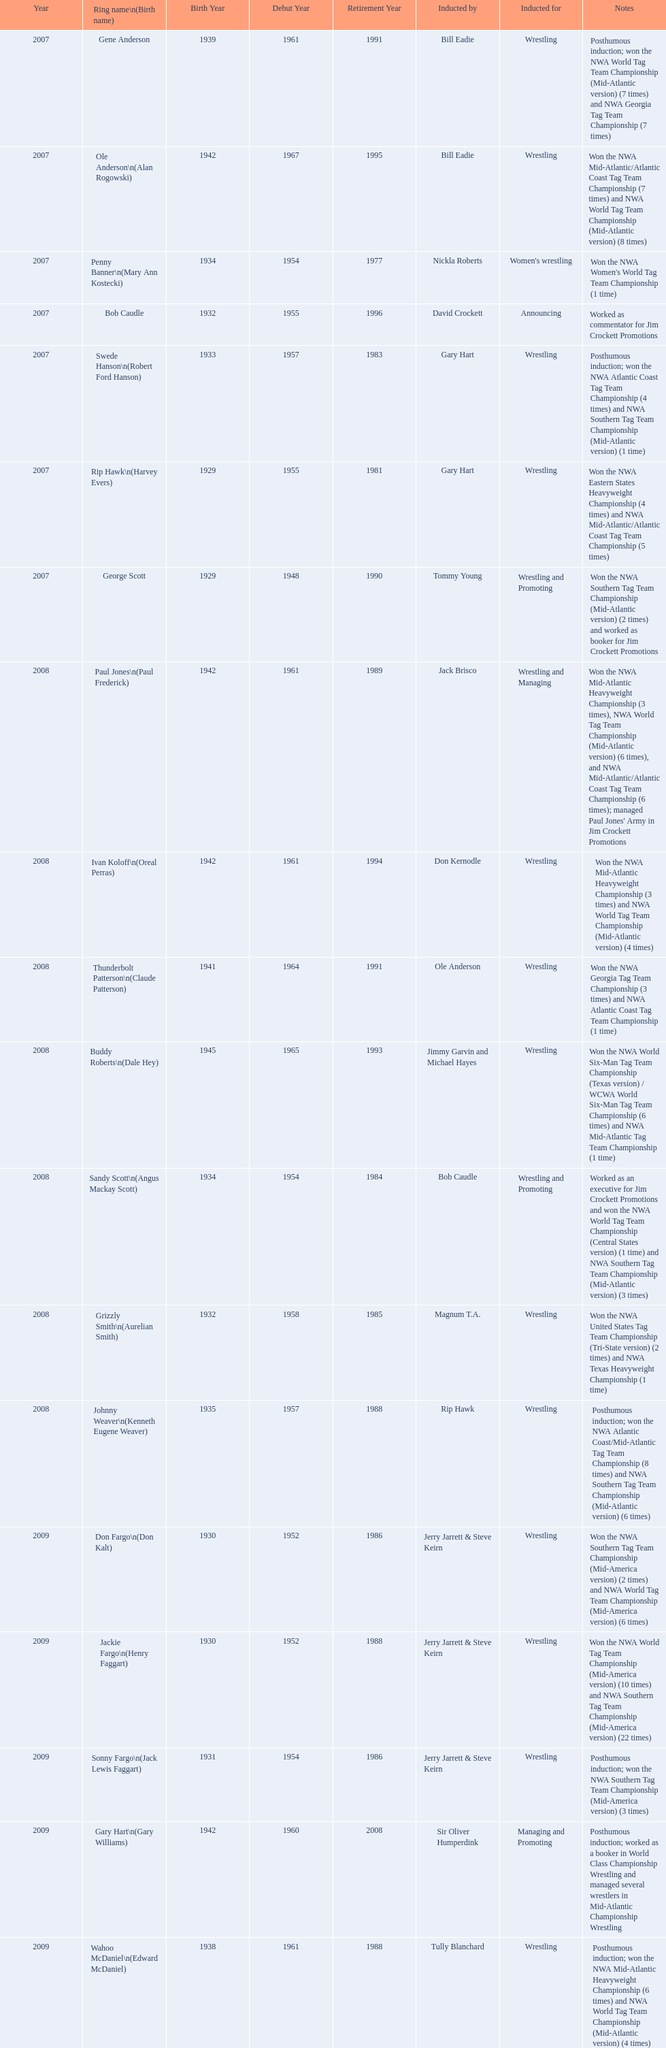What announcers were inducted? Bob Caudle, Lance Russell. What announcer was inducted in 2009? Lance Russell. 